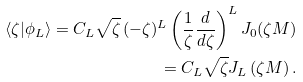<formula> <loc_0><loc_0><loc_500><loc_500>\langle \zeta | \phi _ { L } \rangle = C _ { L } \sqrt { \zeta } \, ( - \zeta ) ^ { L } \left ( \frac { 1 } { \zeta } \frac { d } { d \zeta } \right ) ^ { L } J _ { 0 } ( \zeta M ) \\ = C _ { L } \sqrt { \zeta } J _ { L } \left ( \zeta M \right ) .</formula> 